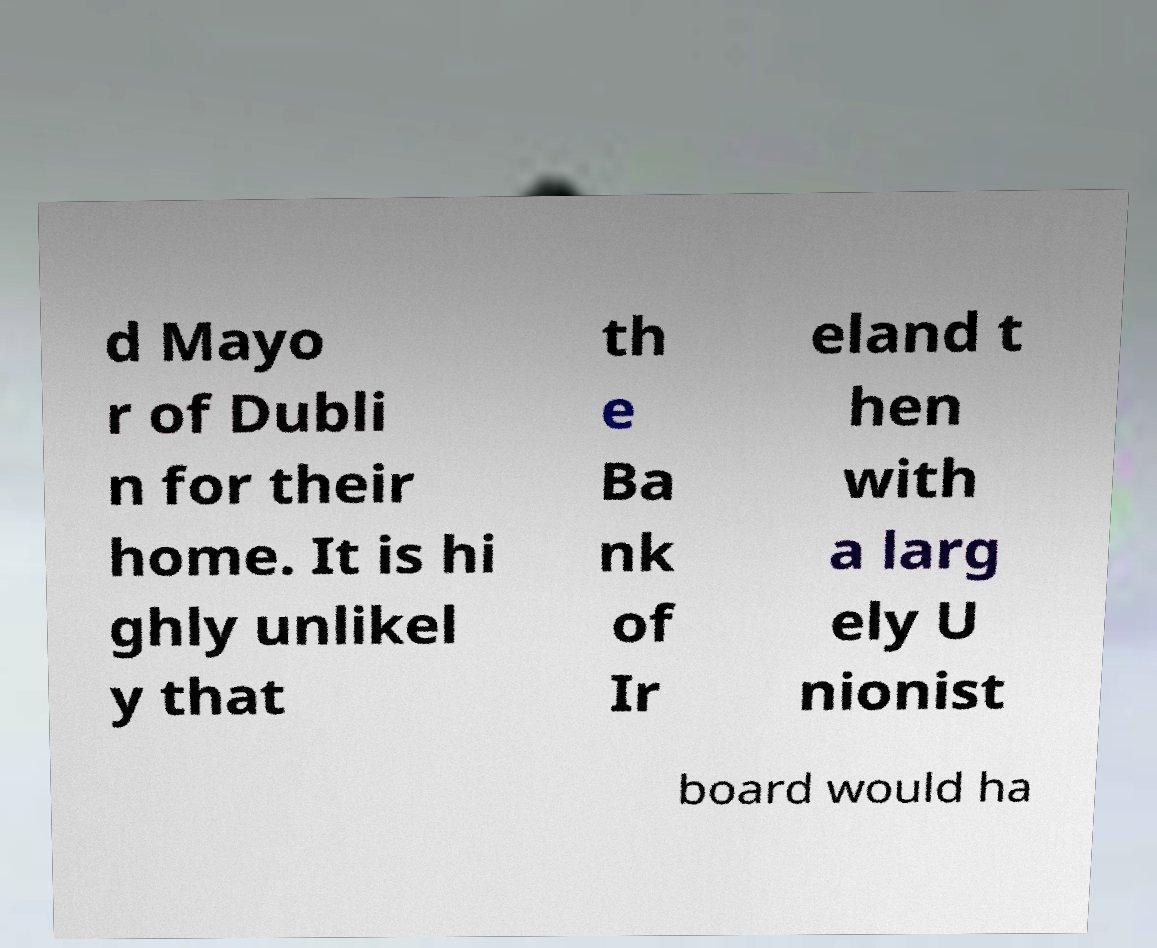Could you assist in decoding the text presented in this image and type it out clearly? d Mayo r of Dubli n for their home. It is hi ghly unlikel y that th e Ba nk of Ir eland t hen with a larg ely U nionist board would ha 